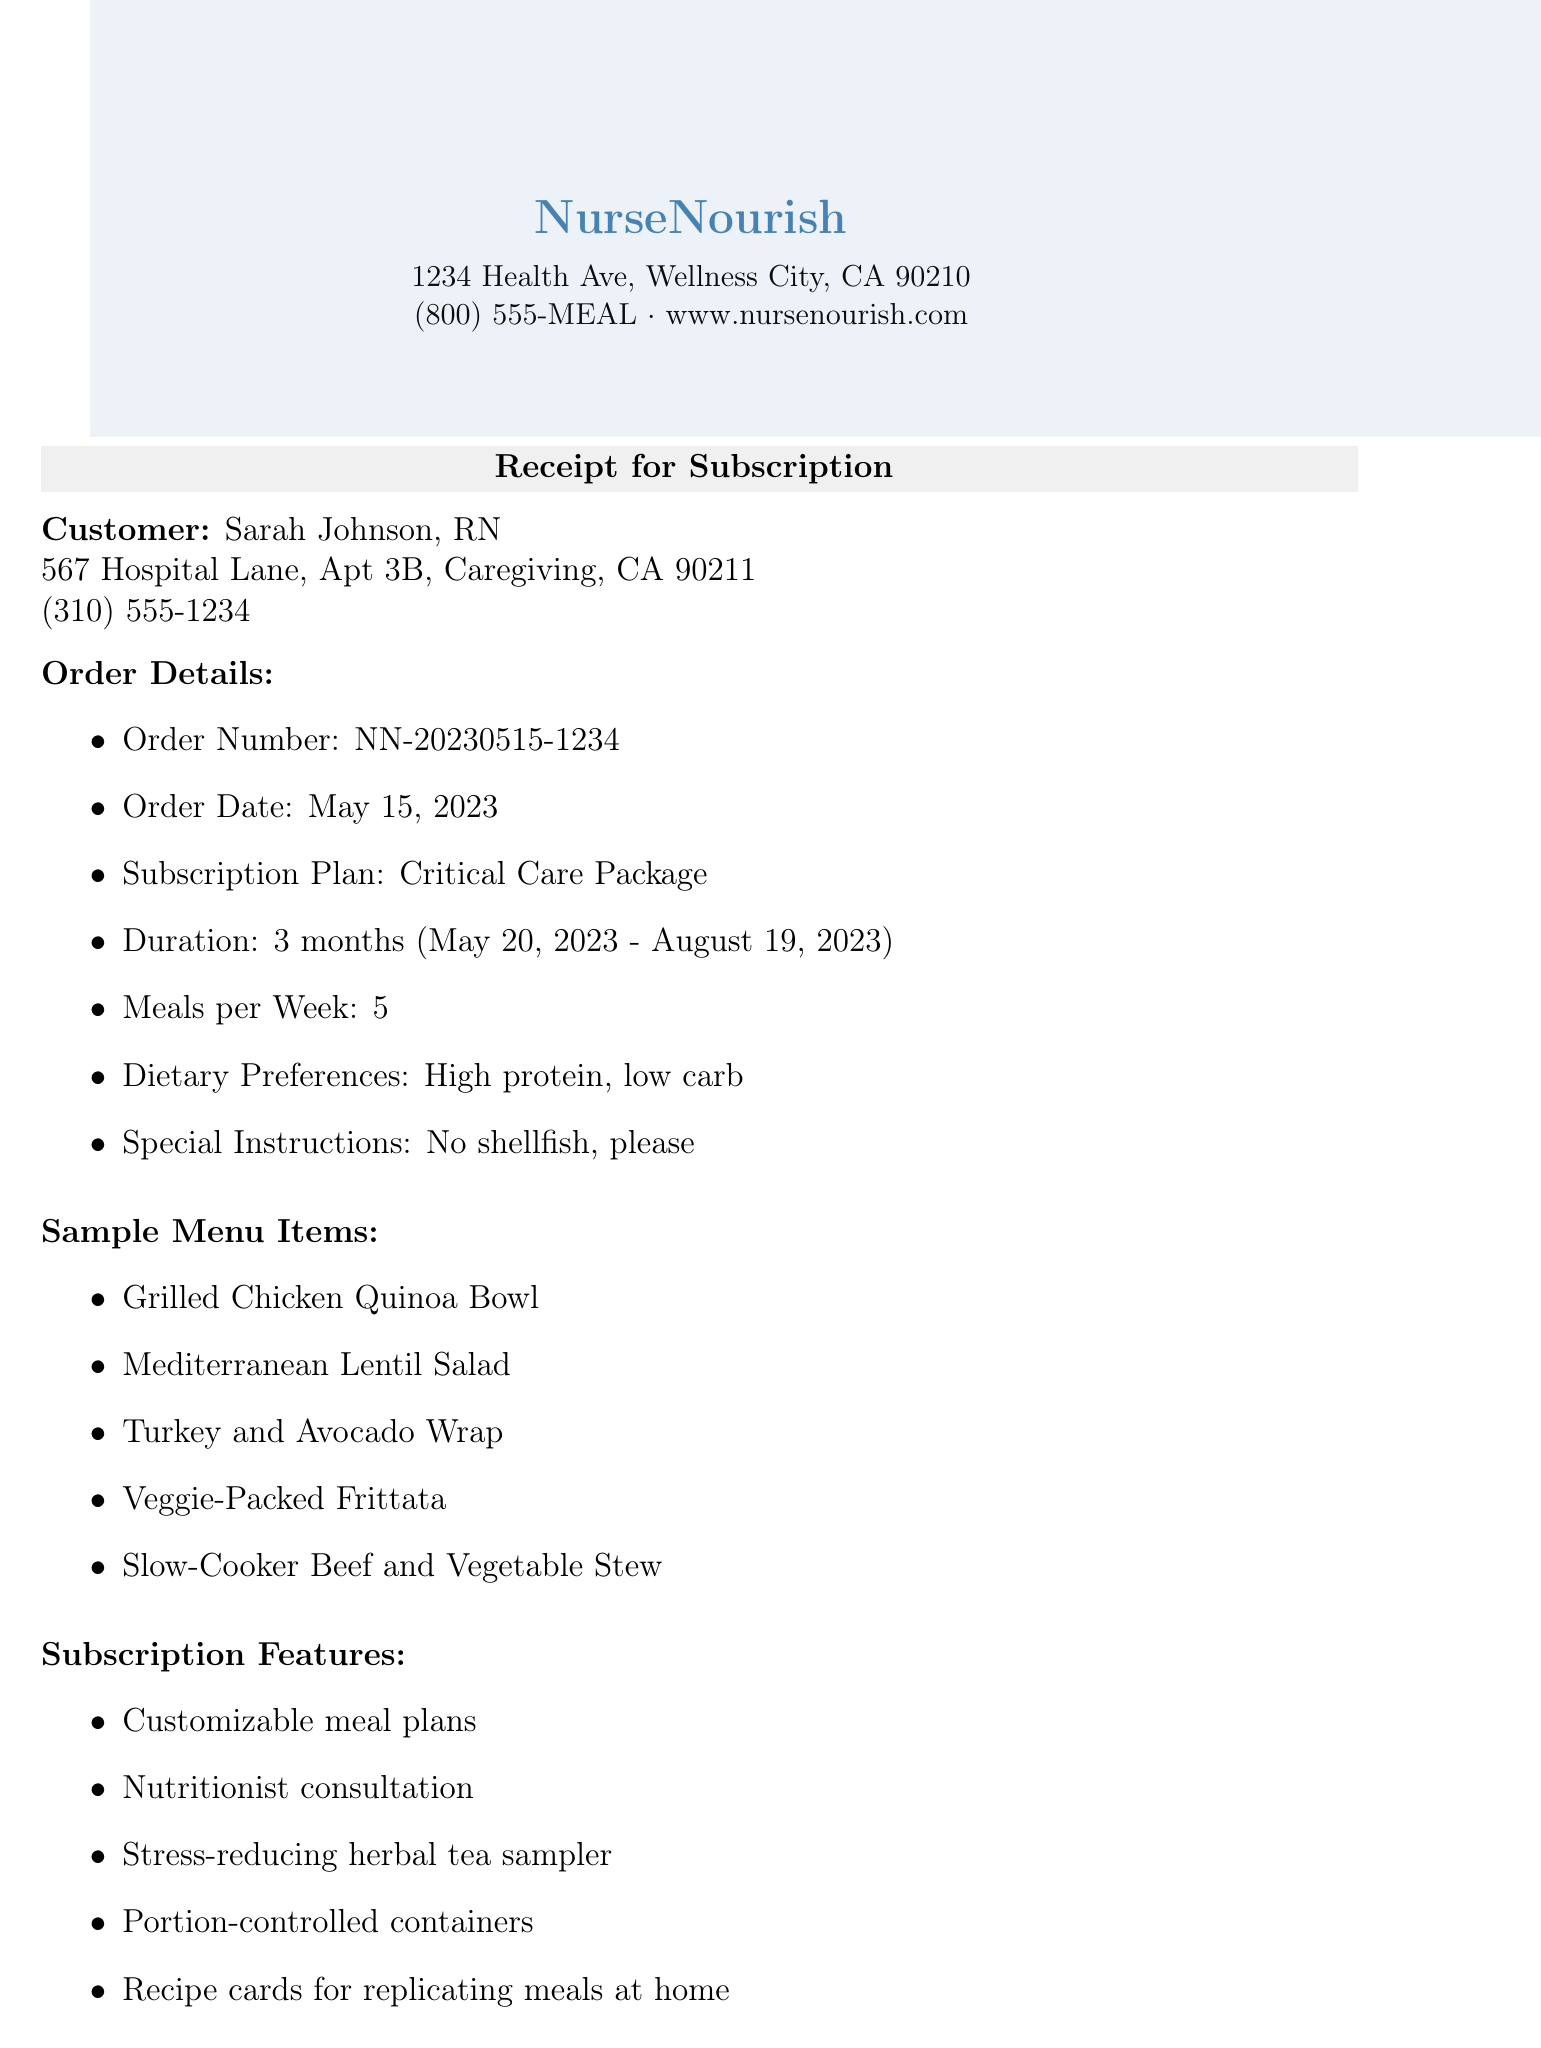What is the customer's name? The customer's name is clearly stated in the document under "Customer."
Answer: Sarah Johnson, RN What is the order date? The order date is indicated in the section titled "Order Details."
Answer: May 15, 2023 How many meals per week are included in the subscription? The number of meals per week is specified in the "Order Details" section.
Answer: 5 What is the total amount charged for the subscription? The total amount is calculated and presented in the "Pricing" section.
Answer: $1,052.10 What is the duration of the subscription? The duration of the subscription can be found in the "Order Details" section.
Answer: 3 months Which discount was applied to the subscription? The applied discount is noted in the "Pricing" section as part of the pricing breakdown.
Answer: Healthcare Hero Discount What is the next billing date? The next billing date is mentioned under "Billing Frequency."
Answer: June 15, 2023 Can the subscription be canceled anytime? The cancellation policy details are outlined in the document, specifying conditions for cancellation.
Answer: Yes, with 7 days notice What are the special dietary instructions? The special instructions are provided in the "Order Details" section.
Answer: No shellfish, please What are two features included in the subscription? The subscription features are listed under "Subscription Features," allowing for selection of any two.
Answer: Customizable meal plans, Nutritionist consultation 